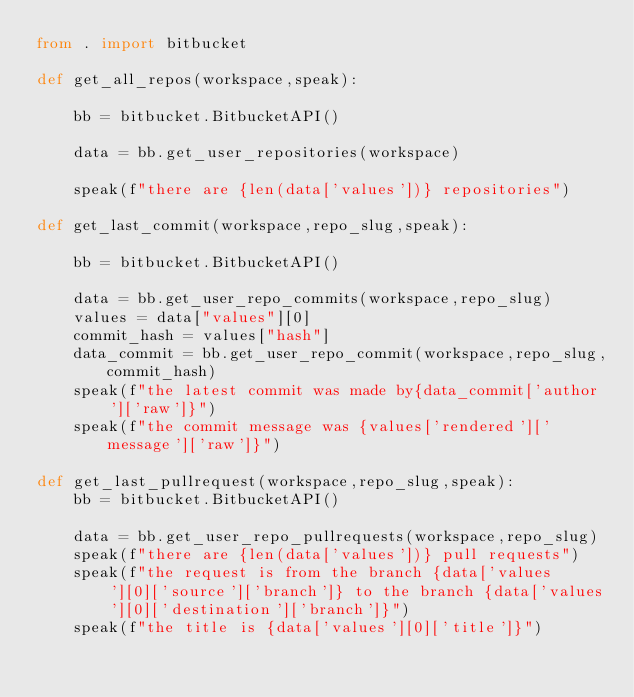Convert code to text. <code><loc_0><loc_0><loc_500><loc_500><_Python_>from . import bitbucket

def get_all_repos(workspace,speak):

	bb = bitbucket.BitbucketAPI()

	data = bb.get_user_repositories(workspace)

	speak(f"there are {len(data['values'])} repositories")

def get_last_commit(workspace,repo_slug,speak):

	bb = bitbucket.BitbucketAPI()

	data = bb.get_user_repo_commits(workspace,repo_slug)
	values = data["values"][0]
	commit_hash = values["hash"]
	data_commit = bb.get_user_repo_commit(workspace,repo_slug,commit_hash)
	speak(f"the latest commit was made by{data_commit['author']['raw']}")
	speak(f"the commit message was {values['rendered']['message']['raw']}")

def get_last_pullrequest(workspace,repo_slug,speak):
	bb = bitbucket.BitbucketAPI()

	data = bb.get_user_repo_pullrequests(workspace,repo_slug)
	speak(f"there are {len(data['values'])} pull requests")
	speak(f"the request is from the branch {data['values'][0]['source']['branch']} to the branch {data['values'][0]['destination']['branch']}")
	speak(f"the title is {data['values'][0]['title']}")</code> 